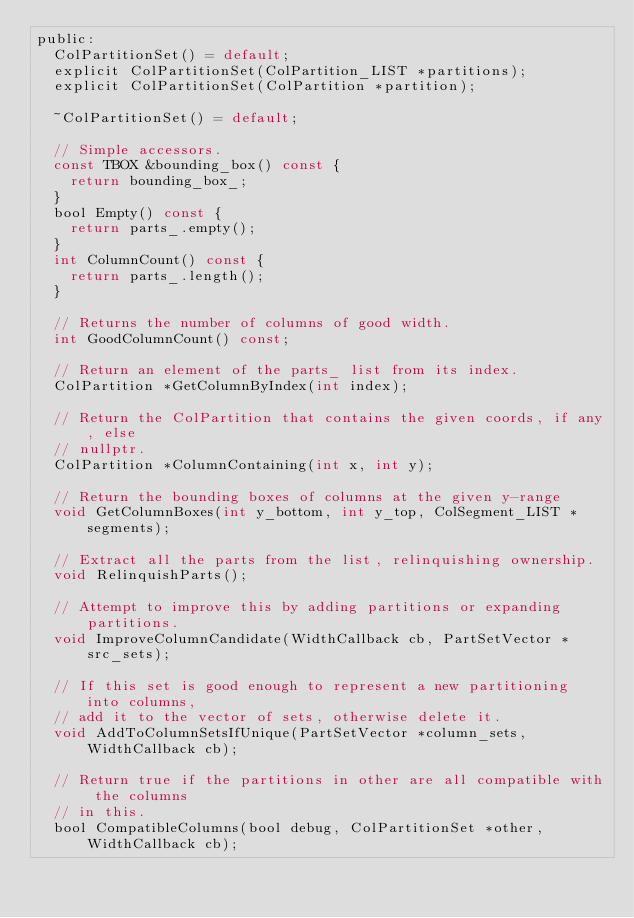Convert code to text. <code><loc_0><loc_0><loc_500><loc_500><_C_>public:
  ColPartitionSet() = default;
  explicit ColPartitionSet(ColPartition_LIST *partitions);
  explicit ColPartitionSet(ColPartition *partition);

  ~ColPartitionSet() = default;

  // Simple accessors.
  const TBOX &bounding_box() const {
    return bounding_box_;
  }
  bool Empty() const {
    return parts_.empty();
  }
  int ColumnCount() const {
    return parts_.length();
  }

  // Returns the number of columns of good width.
  int GoodColumnCount() const;

  // Return an element of the parts_ list from its index.
  ColPartition *GetColumnByIndex(int index);

  // Return the ColPartition that contains the given coords, if any, else
  // nullptr.
  ColPartition *ColumnContaining(int x, int y);

  // Return the bounding boxes of columns at the given y-range
  void GetColumnBoxes(int y_bottom, int y_top, ColSegment_LIST *segments);

  // Extract all the parts from the list, relinquishing ownership.
  void RelinquishParts();

  // Attempt to improve this by adding partitions or expanding partitions.
  void ImproveColumnCandidate(WidthCallback cb, PartSetVector *src_sets);

  // If this set is good enough to represent a new partitioning into columns,
  // add it to the vector of sets, otherwise delete it.
  void AddToColumnSetsIfUnique(PartSetVector *column_sets, WidthCallback cb);

  // Return true if the partitions in other are all compatible with the columns
  // in this.
  bool CompatibleColumns(bool debug, ColPartitionSet *other, WidthCallback cb);</code> 